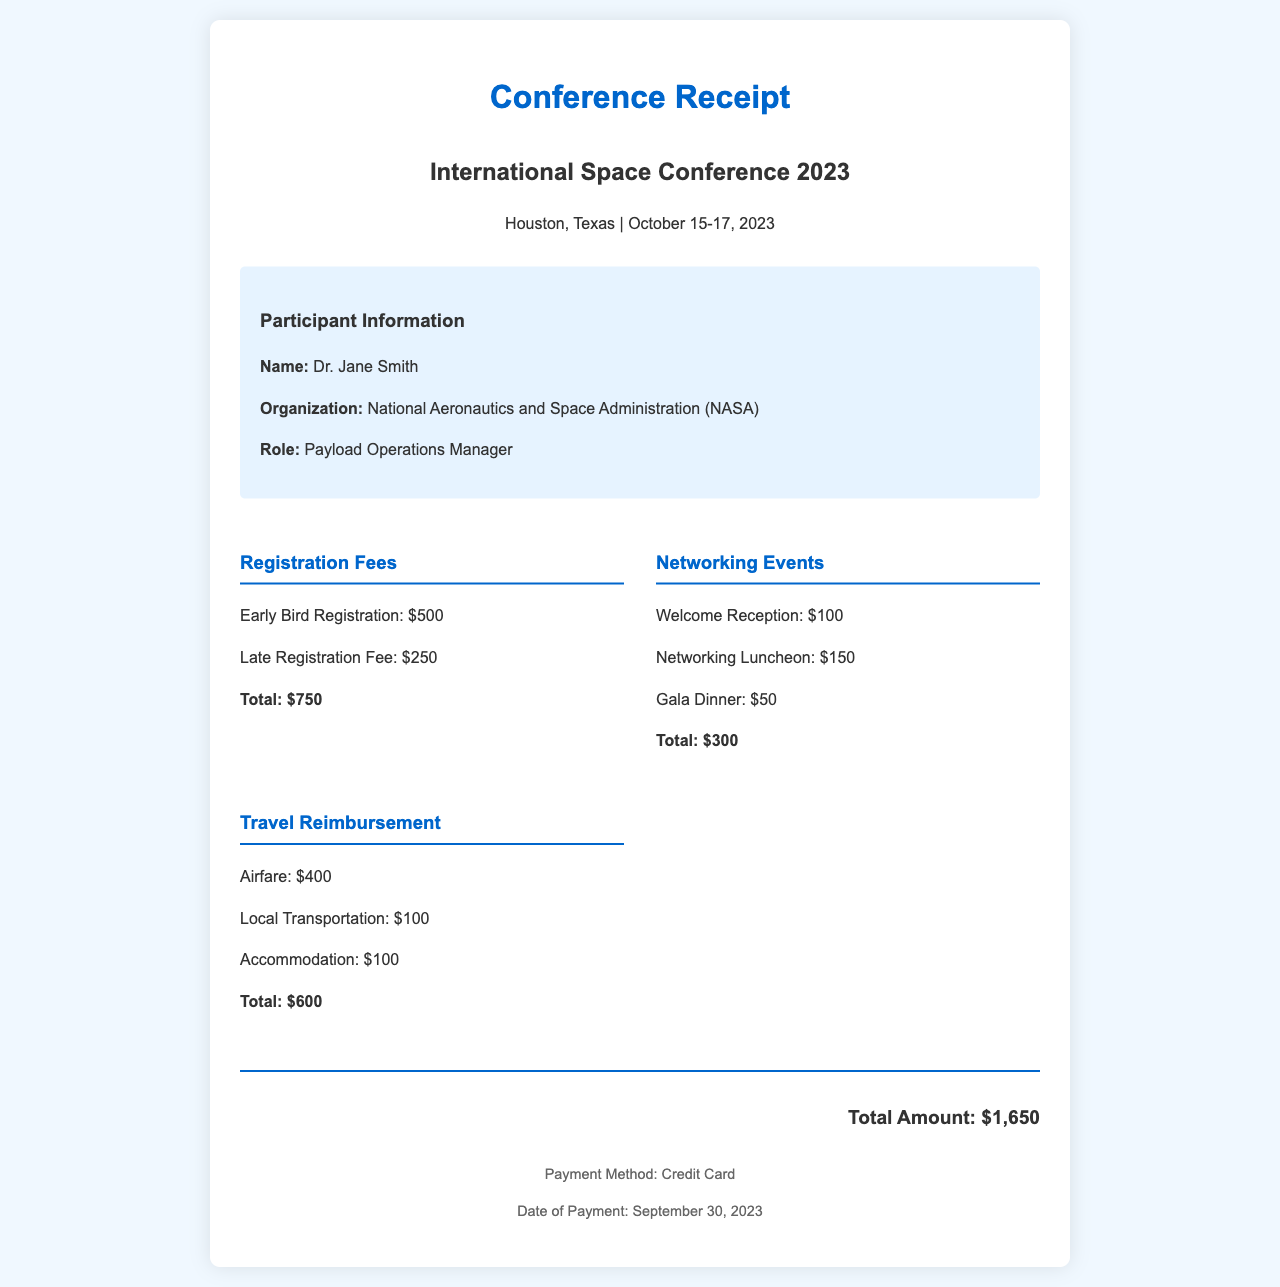What is the total amount for registration fees? The total amount for registration fees is the sum of the Early Bird Registration and Late Registration Fee, which is $500 + $250.
Answer: $750 What is the cost of the Welcome Reception? The cost of the Welcome Reception is explicitly listed under Networking Events in the document.
Answer: $100 Who is the participant mentioned in the receipt? The participant's name is provided at the start of the participant information section.
Answer: Dr. Jane Smith What is the date of payment? The date of payment is specified in the footer section of the receipt.
Answer: September 30, 2023 How much is allocated for local transportation in travel reimbursement? The local transportation amount is detailed in the travel reimbursement section of the document.
Answer: $100 What is the total cost for Networking Events? The total cost for Networking Events is the sum of all specified events in that section, $100 + $150 + $50.
Answer: $300 What type of payment method was used? The payment method is explicitly stated in the footer section of the receipt.
Answer: Credit Card What city hosted the International Space Conference 2023? The hosting city is mentioned in the header of the receipt.
Answer: Houston How much is the airfare reimbursement? The airfare reimbursement amount is specifically listed in the travel reimbursement section.
Answer: $400 